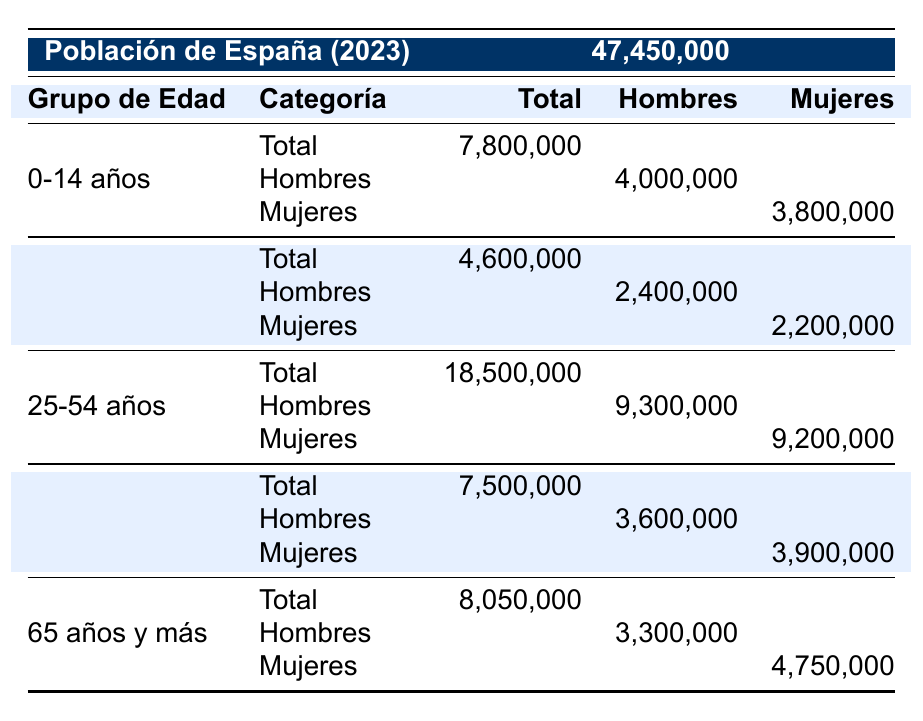What is the total population of Spain in 2023? The total population is stated in the table as 47,450,000.
Answer: 47,450,000 How many males are in the 25-54 age group? The number of males in the 25-54 years age group is specified in the table as 9,300,000.
Answer: 9,300,000 What is the total number of females aged 65 years and over? The table shows that the total number of females aged 65 years and over is 4,750,000.
Answer: 4,750,000 Are there more females than males in the age group of 55-64 years? In the 55-64 years age group, there are 3,900,000 females and 3,600,000 males. Since 3,900,000 is greater than 3,600,000, the statement is true.
Answer: Yes What is the sum of the total population in the age groups 0-14 years and 15-24 years? The total population for 0-14 years is 7,800,000 and for 15-24 years is 4,600,000. Adding them gives 7,800,000 + 4,600,000 = 12,400,000.
Answer: 12,400,000 What percentage of the total population are males aged 0-14 years? The total number of males aged 0-14 years is 4,000,000, and the total population is 47,450,000. To find the percentage, the formula is (4,000,000 / 47,450,000) * 100, which equals approximately 8.43%.
Answer: 8.43% How many more females are there in the 65 years and over age group than in the 0-14 years age group? In the 65 years and over group, there are 4,750,000 females, and in the 0-14 years group, there are 3,800,000 females. The difference is calculated as 4,750,000 - 3,800,000 = 950,000.
Answer: 950,000 What is the average number of males across all age groups listed? The total number of males in each age group is 4,000,000 (0-14) + 2,400,000 (15-24) + 9,300,000 (25-54) + 3,600,000 (55-64) + 3,300,000 (65+) = 22,600,000. There are 5 age groups, so the average is 22,600,000 / 5 = 4,520,000.
Answer: 4,520,000 Is the total population of males aged 0-14 years greater than that of females aged 55-64 years? Males aged 0-14 years total 4,000,000 and females aged 55-64 years total 3,900,000. Since 4,000,000 is greater than 3,900,000, the answer is yes.
Answer: Yes 